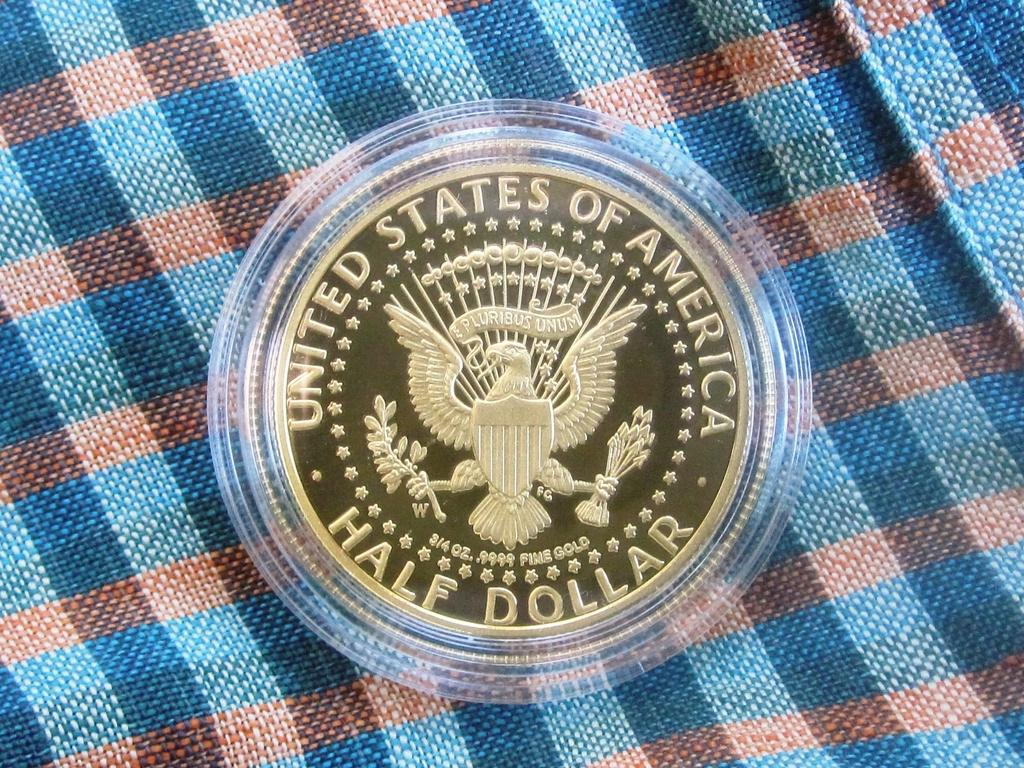What object is the main focus of the image? There is a coin in the image. What is the coin placed on? The coin is on a cloth. Can you describe the colors of the cloth? The cloth has blue and brown colors. What is the texture of the cloth in the image? The texture of the cloth cannot be determined from the image alone, as it only provides visual information about the colors. 